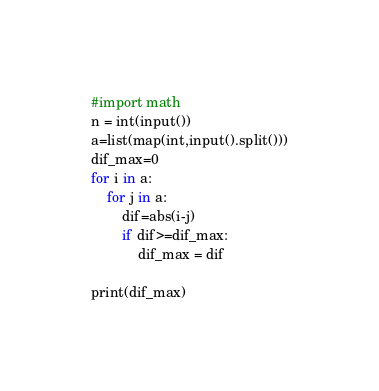Convert code to text. <code><loc_0><loc_0><loc_500><loc_500><_Python_>#import math
n = int(input())
a=list(map(int,input().split()))
dif_max=0
for i in a:
    for j in a:
        dif=abs(i-j)
        if dif>=dif_max:
            dif_max = dif

print(dif_max)
</code> 